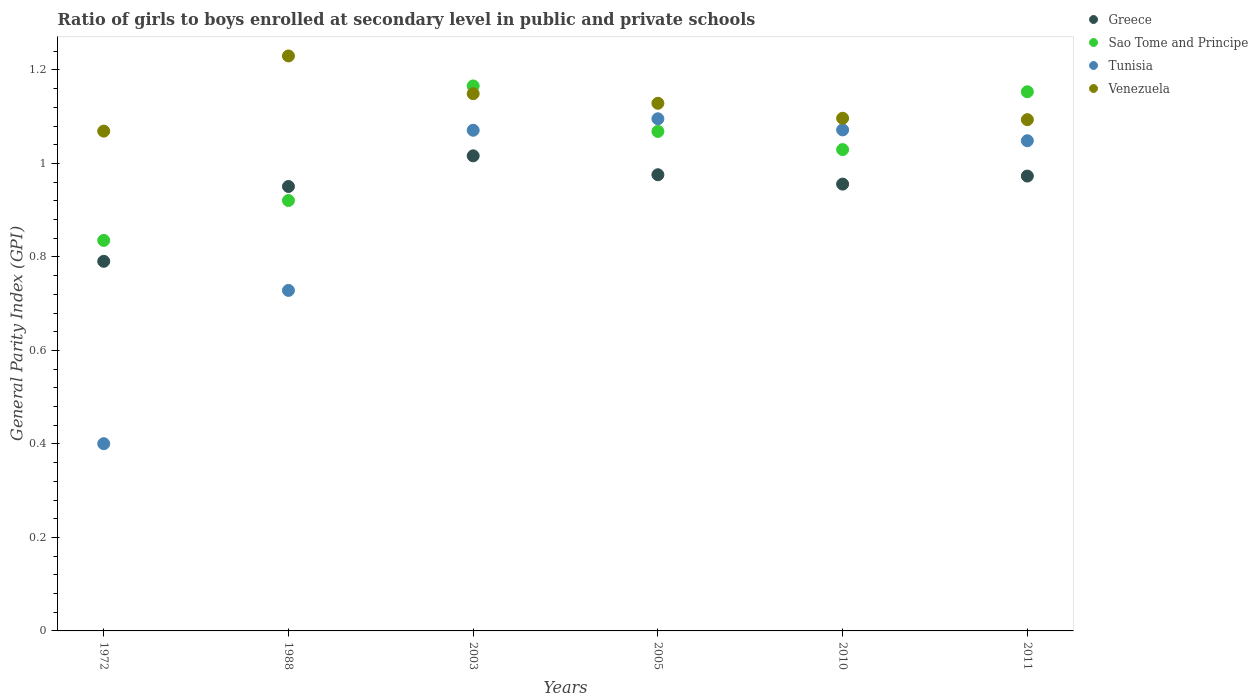Is the number of dotlines equal to the number of legend labels?
Keep it short and to the point. Yes. What is the general parity index in Greece in 1988?
Your answer should be very brief. 0.95. Across all years, what is the maximum general parity index in Sao Tome and Principe?
Give a very brief answer. 1.17. Across all years, what is the minimum general parity index in Venezuela?
Offer a terse response. 1.07. In which year was the general parity index in Greece maximum?
Provide a short and direct response. 2003. In which year was the general parity index in Venezuela minimum?
Provide a succinct answer. 1972. What is the total general parity index in Sao Tome and Principe in the graph?
Your response must be concise. 6.17. What is the difference between the general parity index in Sao Tome and Principe in 1972 and that in 2010?
Your answer should be compact. -0.19. What is the difference between the general parity index in Greece in 1988 and the general parity index in Venezuela in 2005?
Give a very brief answer. -0.18. What is the average general parity index in Tunisia per year?
Your answer should be compact. 0.9. In the year 2005, what is the difference between the general parity index in Tunisia and general parity index in Venezuela?
Offer a terse response. -0.03. In how many years, is the general parity index in Venezuela greater than 1.2000000000000002?
Offer a terse response. 1. What is the ratio of the general parity index in Venezuela in 1988 to that in 2003?
Provide a short and direct response. 1.07. What is the difference between the highest and the second highest general parity index in Greece?
Offer a very short reply. 0.04. What is the difference between the highest and the lowest general parity index in Venezuela?
Offer a very short reply. 0.16. In how many years, is the general parity index in Venezuela greater than the average general parity index in Venezuela taken over all years?
Make the answer very short. 3. Is the sum of the general parity index in Sao Tome and Principe in 2003 and 2010 greater than the maximum general parity index in Tunisia across all years?
Ensure brevity in your answer.  Yes. Is it the case that in every year, the sum of the general parity index in Sao Tome and Principe and general parity index in Venezuela  is greater than the sum of general parity index in Greece and general parity index in Tunisia?
Give a very brief answer. No. Is it the case that in every year, the sum of the general parity index in Venezuela and general parity index in Tunisia  is greater than the general parity index in Greece?
Ensure brevity in your answer.  Yes. How many dotlines are there?
Give a very brief answer. 4. What is the difference between two consecutive major ticks on the Y-axis?
Provide a short and direct response. 0.2. Does the graph contain any zero values?
Your response must be concise. No. How many legend labels are there?
Ensure brevity in your answer.  4. What is the title of the graph?
Keep it short and to the point. Ratio of girls to boys enrolled at secondary level in public and private schools. What is the label or title of the Y-axis?
Provide a succinct answer. General Parity Index (GPI). What is the General Parity Index (GPI) of Greece in 1972?
Offer a very short reply. 0.79. What is the General Parity Index (GPI) in Sao Tome and Principe in 1972?
Provide a short and direct response. 0.84. What is the General Parity Index (GPI) in Tunisia in 1972?
Offer a terse response. 0.4. What is the General Parity Index (GPI) of Venezuela in 1972?
Provide a succinct answer. 1.07. What is the General Parity Index (GPI) of Greece in 1988?
Make the answer very short. 0.95. What is the General Parity Index (GPI) in Sao Tome and Principe in 1988?
Offer a terse response. 0.92. What is the General Parity Index (GPI) of Tunisia in 1988?
Your answer should be compact. 0.73. What is the General Parity Index (GPI) of Venezuela in 1988?
Give a very brief answer. 1.23. What is the General Parity Index (GPI) of Greece in 2003?
Your answer should be very brief. 1.02. What is the General Parity Index (GPI) in Sao Tome and Principe in 2003?
Provide a short and direct response. 1.17. What is the General Parity Index (GPI) in Tunisia in 2003?
Keep it short and to the point. 1.07. What is the General Parity Index (GPI) of Venezuela in 2003?
Your answer should be compact. 1.15. What is the General Parity Index (GPI) of Greece in 2005?
Your response must be concise. 0.98. What is the General Parity Index (GPI) of Sao Tome and Principe in 2005?
Your answer should be compact. 1.07. What is the General Parity Index (GPI) of Tunisia in 2005?
Give a very brief answer. 1.1. What is the General Parity Index (GPI) in Venezuela in 2005?
Your answer should be compact. 1.13. What is the General Parity Index (GPI) in Greece in 2010?
Give a very brief answer. 0.96. What is the General Parity Index (GPI) of Sao Tome and Principe in 2010?
Make the answer very short. 1.03. What is the General Parity Index (GPI) in Tunisia in 2010?
Provide a succinct answer. 1.07. What is the General Parity Index (GPI) of Venezuela in 2010?
Ensure brevity in your answer.  1.1. What is the General Parity Index (GPI) of Greece in 2011?
Provide a succinct answer. 0.97. What is the General Parity Index (GPI) in Sao Tome and Principe in 2011?
Provide a short and direct response. 1.15. What is the General Parity Index (GPI) in Tunisia in 2011?
Your response must be concise. 1.05. What is the General Parity Index (GPI) of Venezuela in 2011?
Give a very brief answer. 1.09. Across all years, what is the maximum General Parity Index (GPI) of Greece?
Offer a very short reply. 1.02. Across all years, what is the maximum General Parity Index (GPI) of Sao Tome and Principe?
Ensure brevity in your answer.  1.17. Across all years, what is the maximum General Parity Index (GPI) in Tunisia?
Your answer should be very brief. 1.1. Across all years, what is the maximum General Parity Index (GPI) in Venezuela?
Your answer should be very brief. 1.23. Across all years, what is the minimum General Parity Index (GPI) in Greece?
Offer a terse response. 0.79. Across all years, what is the minimum General Parity Index (GPI) in Sao Tome and Principe?
Offer a very short reply. 0.84. Across all years, what is the minimum General Parity Index (GPI) of Tunisia?
Keep it short and to the point. 0.4. Across all years, what is the minimum General Parity Index (GPI) in Venezuela?
Make the answer very short. 1.07. What is the total General Parity Index (GPI) in Greece in the graph?
Make the answer very short. 5.66. What is the total General Parity Index (GPI) of Sao Tome and Principe in the graph?
Ensure brevity in your answer.  6.17. What is the total General Parity Index (GPI) of Tunisia in the graph?
Your response must be concise. 5.42. What is the total General Parity Index (GPI) in Venezuela in the graph?
Your response must be concise. 6.77. What is the difference between the General Parity Index (GPI) of Greece in 1972 and that in 1988?
Keep it short and to the point. -0.16. What is the difference between the General Parity Index (GPI) in Sao Tome and Principe in 1972 and that in 1988?
Give a very brief answer. -0.09. What is the difference between the General Parity Index (GPI) in Tunisia in 1972 and that in 1988?
Your answer should be compact. -0.33. What is the difference between the General Parity Index (GPI) of Venezuela in 1972 and that in 1988?
Give a very brief answer. -0.16. What is the difference between the General Parity Index (GPI) of Greece in 1972 and that in 2003?
Offer a very short reply. -0.23. What is the difference between the General Parity Index (GPI) of Sao Tome and Principe in 1972 and that in 2003?
Provide a succinct answer. -0.33. What is the difference between the General Parity Index (GPI) in Tunisia in 1972 and that in 2003?
Your answer should be compact. -0.67. What is the difference between the General Parity Index (GPI) in Venezuela in 1972 and that in 2003?
Make the answer very short. -0.08. What is the difference between the General Parity Index (GPI) of Greece in 1972 and that in 2005?
Offer a very short reply. -0.19. What is the difference between the General Parity Index (GPI) of Sao Tome and Principe in 1972 and that in 2005?
Provide a short and direct response. -0.23. What is the difference between the General Parity Index (GPI) in Tunisia in 1972 and that in 2005?
Provide a succinct answer. -0.69. What is the difference between the General Parity Index (GPI) in Venezuela in 1972 and that in 2005?
Your response must be concise. -0.06. What is the difference between the General Parity Index (GPI) of Greece in 1972 and that in 2010?
Give a very brief answer. -0.17. What is the difference between the General Parity Index (GPI) of Sao Tome and Principe in 1972 and that in 2010?
Your answer should be very brief. -0.19. What is the difference between the General Parity Index (GPI) of Tunisia in 1972 and that in 2010?
Offer a terse response. -0.67. What is the difference between the General Parity Index (GPI) in Venezuela in 1972 and that in 2010?
Provide a succinct answer. -0.03. What is the difference between the General Parity Index (GPI) of Greece in 1972 and that in 2011?
Provide a succinct answer. -0.18. What is the difference between the General Parity Index (GPI) in Sao Tome and Principe in 1972 and that in 2011?
Ensure brevity in your answer.  -0.32. What is the difference between the General Parity Index (GPI) in Tunisia in 1972 and that in 2011?
Your response must be concise. -0.65. What is the difference between the General Parity Index (GPI) in Venezuela in 1972 and that in 2011?
Make the answer very short. -0.02. What is the difference between the General Parity Index (GPI) in Greece in 1988 and that in 2003?
Offer a terse response. -0.07. What is the difference between the General Parity Index (GPI) of Sao Tome and Principe in 1988 and that in 2003?
Keep it short and to the point. -0.25. What is the difference between the General Parity Index (GPI) in Tunisia in 1988 and that in 2003?
Give a very brief answer. -0.34. What is the difference between the General Parity Index (GPI) of Venezuela in 1988 and that in 2003?
Your response must be concise. 0.08. What is the difference between the General Parity Index (GPI) in Greece in 1988 and that in 2005?
Give a very brief answer. -0.03. What is the difference between the General Parity Index (GPI) of Sao Tome and Principe in 1988 and that in 2005?
Offer a terse response. -0.15. What is the difference between the General Parity Index (GPI) of Tunisia in 1988 and that in 2005?
Give a very brief answer. -0.37. What is the difference between the General Parity Index (GPI) of Venezuela in 1988 and that in 2005?
Provide a succinct answer. 0.1. What is the difference between the General Parity Index (GPI) in Greece in 1988 and that in 2010?
Your response must be concise. -0.01. What is the difference between the General Parity Index (GPI) in Sao Tome and Principe in 1988 and that in 2010?
Your answer should be compact. -0.11. What is the difference between the General Parity Index (GPI) of Tunisia in 1988 and that in 2010?
Provide a succinct answer. -0.34. What is the difference between the General Parity Index (GPI) in Venezuela in 1988 and that in 2010?
Give a very brief answer. 0.13. What is the difference between the General Parity Index (GPI) in Greece in 1988 and that in 2011?
Ensure brevity in your answer.  -0.02. What is the difference between the General Parity Index (GPI) in Sao Tome and Principe in 1988 and that in 2011?
Make the answer very short. -0.23. What is the difference between the General Parity Index (GPI) in Tunisia in 1988 and that in 2011?
Ensure brevity in your answer.  -0.32. What is the difference between the General Parity Index (GPI) of Venezuela in 1988 and that in 2011?
Offer a terse response. 0.14. What is the difference between the General Parity Index (GPI) in Greece in 2003 and that in 2005?
Offer a very short reply. 0.04. What is the difference between the General Parity Index (GPI) of Sao Tome and Principe in 2003 and that in 2005?
Your answer should be compact. 0.1. What is the difference between the General Parity Index (GPI) in Tunisia in 2003 and that in 2005?
Give a very brief answer. -0.02. What is the difference between the General Parity Index (GPI) in Venezuela in 2003 and that in 2005?
Offer a terse response. 0.02. What is the difference between the General Parity Index (GPI) of Greece in 2003 and that in 2010?
Ensure brevity in your answer.  0.06. What is the difference between the General Parity Index (GPI) in Sao Tome and Principe in 2003 and that in 2010?
Provide a succinct answer. 0.14. What is the difference between the General Parity Index (GPI) in Tunisia in 2003 and that in 2010?
Keep it short and to the point. -0. What is the difference between the General Parity Index (GPI) of Venezuela in 2003 and that in 2010?
Give a very brief answer. 0.05. What is the difference between the General Parity Index (GPI) in Greece in 2003 and that in 2011?
Offer a very short reply. 0.04. What is the difference between the General Parity Index (GPI) in Sao Tome and Principe in 2003 and that in 2011?
Keep it short and to the point. 0.01. What is the difference between the General Parity Index (GPI) of Tunisia in 2003 and that in 2011?
Give a very brief answer. 0.02. What is the difference between the General Parity Index (GPI) of Venezuela in 2003 and that in 2011?
Your answer should be very brief. 0.06. What is the difference between the General Parity Index (GPI) of Greece in 2005 and that in 2010?
Give a very brief answer. 0.02. What is the difference between the General Parity Index (GPI) of Sao Tome and Principe in 2005 and that in 2010?
Give a very brief answer. 0.04. What is the difference between the General Parity Index (GPI) in Tunisia in 2005 and that in 2010?
Offer a very short reply. 0.02. What is the difference between the General Parity Index (GPI) in Venezuela in 2005 and that in 2010?
Offer a terse response. 0.03. What is the difference between the General Parity Index (GPI) of Greece in 2005 and that in 2011?
Provide a short and direct response. 0. What is the difference between the General Parity Index (GPI) of Sao Tome and Principe in 2005 and that in 2011?
Your answer should be compact. -0.08. What is the difference between the General Parity Index (GPI) in Tunisia in 2005 and that in 2011?
Give a very brief answer. 0.05. What is the difference between the General Parity Index (GPI) of Venezuela in 2005 and that in 2011?
Ensure brevity in your answer.  0.04. What is the difference between the General Parity Index (GPI) of Greece in 2010 and that in 2011?
Offer a very short reply. -0.02. What is the difference between the General Parity Index (GPI) of Sao Tome and Principe in 2010 and that in 2011?
Provide a succinct answer. -0.12. What is the difference between the General Parity Index (GPI) of Tunisia in 2010 and that in 2011?
Offer a terse response. 0.02. What is the difference between the General Parity Index (GPI) of Venezuela in 2010 and that in 2011?
Give a very brief answer. 0. What is the difference between the General Parity Index (GPI) of Greece in 1972 and the General Parity Index (GPI) of Sao Tome and Principe in 1988?
Provide a succinct answer. -0.13. What is the difference between the General Parity Index (GPI) in Greece in 1972 and the General Parity Index (GPI) in Tunisia in 1988?
Give a very brief answer. 0.06. What is the difference between the General Parity Index (GPI) of Greece in 1972 and the General Parity Index (GPI) of Venezuela in 1988?
Offer a very short reply. -0.44. What is the difference between the General Parity Index (GPI) of Sao Tome and Principe in 1972 and the General Parity Index (GPI) of Tunisia in 1988?
Ensure brevity in your answer.  0.11. What is the difference between the General Parity Index (GPI) in Sao Tome and Principe in 1972 and the General Parity Index (GPI) in Venezuela in 1988?
Provide a succinct answer. -0.39. What is the difference between the General Parity Index (GPI) of Tunisia in 1972 and the General Parity Index (GPI) of Venezuela in 1988?
Give a very brief answer. -0.83. What is the difference between the General Parity Index (GPI) of Greece in 1972 and the General Parity Index (GPI) of Sao Tome and Principe in 2003?
Give a very brief answer. -0.38. What is the difference between the General Parity Index (GPI) in Greece in 1972 and the General Parity Index (GPI) in Tunisia in 2003?
Your answer should be very brief. -0.28. What is the difference between the General Parity Index (GPI) in Greece in 1972 and the General Parity Index (GPI) in Venezuela in 2003?
Provide a succinct answer. -0.36. What is the difference between the General Parity Index (GPI) in Sao Tome and Principe in 1972 and the General Parity Index (GPI) in Tunisia in 2003?
Your answer should be compact. -0.24. What is the difference between the General Parity Index (GPI) in Sao Tome and Principe in 1972 and the General Parity Index (GPI) in Venezuela in 2003?
Provide a short and direct response. -0.31. What is the difference between the General Parity Index (GPI) in Tunisia in 1972 and the General Parity Index (GPI) in Venezuela in 2003?
Provide a short and direct response. -0.75. What is the difference between the General Parity Index (GPI) in Greece in 1972 and the General Parity Index (GPI) in Sao Tome and Principe in 2005?
Your answer should be compact. -0.28. What is the difference between the General Parity Index (GPI) of Greece in 1972 and the General Parity Index (GPI) of Tunisia in 2005?
Your answer should be very brief. -0.3. What is the difference between the General Parity Index (GPI) in Greece in 1972 and the General Parity Index (GPI) in Venezuela in 2005?
Your answer should be compact. -0.34. What is the difference between the General Parity Index (GPI) of Sao Tome and Principe in 1972 and the General Parity Index (GPI) of Tunisia in 2005?
Ensure brevity in your answer.  -0.26. What is the difference between the General Parity Index (GPI) of Sao Tome and Principe in 1972 and the General Parity Index (GPI) of Venezuela in 2005?
Offer a terse response. -0.29. What is the difference between the General Parity Index (GPI) of Tunisia in 1972 and the General Parity Index (GPI) of Venezuela in 2005?
Your answer should be very brief. -0.73. What is the difference between the General Parity Index (GPI) in Greece in 1972 and the General Parity Index (GPI) in Sao Tome and Principe in 2010?
Your response must be concise. -0.24. What is the difference between the General Parity Index (GPI) of Greece in 1972 and the General Parity Index (GPI) of Tunisia in 2010?
Offer a terse response. -0.28. What is the difference between the General Parity Index (GPI) of Greece in 1972 and the General Parity Index (GPI) of Venezuela in 2010?
Your response must be concise. -0.31. What is the difference between the General Parity Index (GPI) in Sao Tome and Principe in 1972 and the General Parity Index (GPI) in Tunisia in 2010?
Provide a short and direct response. -0.24. What is the difference between the General Parity Index (GPI) in Sao Tome and Principe in 1972 and the General Parity Index (GPI) in Venezuela in 2010?
Your answer should be compact. -0.26. What is the difference between the General Parity Index (GPI) of Tunisia in 1972 and the General Parity Index (GPI) of Venezuela in 2010?
Your answer should be very brief. -0.7. What is the difference between the General Parity Index (GPI) of Greece in 1972 and the General Parity Index (GPI) of Sao Tome and Principe in 2011?
Give a very brief answer. -0.36. What is the difference between the General Parity Index (GPI) of Greece in 1972 and the General Parity Index (GPI) of Tunisia in 2011?
Provide a succinct answer. -0.26. What is the difference between the General Parity Index (GPI) in Greece in 1972 and the General Parity Index (GPI) in Venezuela in 2011?
Your answer should be compact. -0.3. What is the difference between the General Parity Index (GPI) in Sao Tome and Principe in 1972 and the General Parity Index (GPI) in Tunisia in 2011?
Provide a short and direct response. -0.21. What is the difference between the General Parity Index (GPI) in Sao Tome and Principe in 1972 and the General Parity Index (GPI) in Venezuela in 2011?
Give a very brief answer. -0.26. What is the difference between the General Parity Index (GPI) of Tunisia in 1972 and the General Parity Index (GPI) of Venezuela in 2011?
Keep it short and to the point. -0.69. What is the difference between the General Parity Index (GPI) of Greece in 1988 and the General Parity Index (GPI) of Sao Tome and Principe in 2003?
Give a very brief answer. -0.22. What is the difference between the General Parity Index (GPI) in Greece in 1988 and the General Parity Index (GPI) in Tunisia in 2003?
Keep it short and to the point. -0.12. What is the difference between the General Parity Index (GPI) of Greece in 1988 and the General Parity Index (GPI) of Venezuela in 2003?
Your response must be concise. -0.2. What is the difference between the General Parity Index (GPI) in Sao Tome and Principe in 1988 and the General Parity Index (GPI) in Tunisia in 2003?
Your answer should be compact. -0.15. What is the difference between the General Parity Index (GPI) in Sao Tome and Principe in 1988 and the General Parity Index (GPI) in Venezuela in 2003?
Your answer should be very brief. -0.23. What is the difference between the General Parity Index (GPI) of Tunisia in 1988 and the General Parity Index (GPI) of Venezuela in 2003?
Keep it short and to the point. -0.42. What is the difference between the General Parity Index (GPI) of Greece in 1988 and the General Parity Index (GPI) of Sao Tome and Principe in 2005?
Provide a short and direct response. -0.12. What is the difference between the General Parity Index (GPI) of Greece in 1988 and the General Parity Index (GPI) of Tunisia in 2005?
Your answer should be compact. -0.14. What is the difference between the General Parity Index (GPI) in Greece in 1988 and the General Parity Index (GPI) in Venezuela in 2005?
Keep it short and to the point. -0.18. What is the difference between the General Parity Index (GPI) of Sao Tome and Principe in 1988 and the General Parity Index (GPI) of Tunisia in 2005?
Ensure brevity in your answer.  -0.17. What is the difference between the General Parity Index (GPI) in Sao Tome and Principe in 1988 and the General Parity Index (GPI) in Venezuela in 2005?
Offer a very short reply. -0.21. What is the difference between the General Parity Index (GPI) of Tunisia in 1988 and the General Parity Index (GPI) of Venezuela in 2005?
Provide a short and direct response. -0.4. What is the difference between the General Parity Index (GPI) of Greece in 1988 and the General Parity Index (GPI) of Sao Tome and Principe in 2010?
Your response must be concise. -0.08. What is the difference between the General Parity Index (GPI) of Greece in 1988 and the General Parity Index (GPI) of Tunisia in 2010?
Your response must be concise. -0.12. What is the difference between the General Parity Index (GPI) in Greece in 1988 and the General Parity Index (GPI) in Venezuela in 2010?
Make the answer very short. -0.15. What is the difference between the General Parity Index (GPI) in Sao Tome and Principe in 1988 and the General Parity Index (GPI) in Tunisia in 2010?
Ensure brevity in your answer.  -0.15. What is the difference between the General Parity Index (GPI) in Sao Tome and Principe in 1988 and the General Parity Index (GPI) in Venezuela in 2010?
Ensure brevity in your answer.  -0.18. What is the difference between the General Parity Index (GPI) of Tunisia in 1988 and the General Parity Index (GPI) of Venezuela in 2010?
Provide a short and direct response. -0.37. What is the difference between the General Parity Index (GPI) in Greece in 1988 and the General Parity Index (GPI) in Sao Tome and Principe in 2011?
Offer a very short reply. -0.2. What is the difference between the General Parity Index (GPI) of Greece in 1988 and the General Parity Index (GPI) of Tunisia in 2011?
Make the answer very short. -0.1. What is the difference between the General Parity Index (GPI) in Greece in 1988 and the General Parity Index (GPI) in Venezuela in 2011?
Ensure brevity in your answer.  -0.14. What is the difference between the General Parity Index (GPI) in Sao Tome and Principe in 1988 and the General Parity Index (GPI) in Tunisia in 2011?
Offer a very short reply. -0.13. What is the difference between the General Parity Index (GPI) of Sao Tome and Principe in 1988 and the General Parity Index (GPI) of Venezuela in 2011?
Make the answer very short. -0.17. What is the difference between the General Parity Index (GPI) of Tunisia in 1988 and the General Parity Index (GPI) of Venezuela in 2011?
Keep it short and to the point. -0.37. What is the difference between the General Parity Index (GPI) in Greece in 2003 and the General Parity Index (GPI) in Sao Tome and Principe in 2005?
Make the answer very short. -0.05. What is the difference between the General Parity Index (GPI) of Greece in 2003 and the General Parity Index (GPI) of Tunisia in 2005?
Ensure brevity in your answer.  -0.08. What is the difference between the General Parity Index (GPI) of Greece in 2003 and the General Parity Index (GPI) of Venezuela in 2005?
Offer a terse response. -0.11. What is the difference between the General Parity Index (GPI) of Sao Tome and Principe in 2003 and the General Parity Index (GPI) of Tunisia in 2005?
Offer a terse response. 0.07. What is the difference between the General Parity Index (GPI) in Sao Tome and Principe in 2003 and the General Parity Index (GPI) in Venezuela in 2005?
Your response must be concise. 0.04. What is the difference between the General Parity Index (GPI) in Tunisia in 2003 and the General Parity Index (GPI) in Venezuela in 2005?
Your answer should be compact. -0.06. What is the difference between the General Parity Index (GPI) in Greece in 2003 and the General Parity Index (GPI) in Sao Tome and Principe in 2010?
Offer a very short reply. -0.01. What is the difference between the General Parity Index (GPI) in Greece in 2003 and the General Parity Index (GPI) in Tunisia in 2010?
Offer a terse response. -0.06. What is the difference between the General Parity Index (GPI) of Greece in 2003 and the General Parity Index (GPI) of Venezuela in 2010?
Your answer should be very brief. -0.08. What is the difference between the General Parity Index (GPI) in Sao Tome and Principe in 2003 and the General Parity Index (GPI) in Tunisia in 2010?
Keep it short and to the point. 0.09. What is the difference between the General Parity Index (GPI) in Sao Tome and Principe in 2003 and the General Parity Index (GPI) in Venezuela in 2010?
Your response must be concise. 0.07. What is the difference between the General Parity Index (GPI) of Tunisia in 2003 and the General Parity Index (GPI) of Venezuela in 2010?
Your response must be concise. -0.03. What is the difference between the General Parity Index (GPI) in Greece in 2003 and the General Parity Index (GPI) in Sao Tome and Principe in 2011?
Your answer should be very brief. -0.14. What is the difference between the General Parity Index (GPI) in Greece in 2003 and the General Parity Index (GPI) in Tunisia in 2011?
Make the answer very short. -0.03. What is the difference between the General Parity Index (GPI) of Greece in 2003 and the General Parity Index (GPI) of Venezuela in 2011?
Provide a succinct answer. -0.08. What is the difference between the General Parity Index (GPI) in Sao Tome and Principe in 2003 and the General Parity Index (GPI) in Tunisia in 2011?
Your answer should be very brief. 0.12. What is the difference between the General Parity Index (GPI) of Sao Tome and Principe in 2003 and the General Parity Index (GPI) of Venezuela in 2011?
Ensure brevity in your answer.  0.07. What is the difference between the General Parity Index (GPI) in Tunisia in 2003 and the General Parity Index (GPI) in Venezuela in 2011?
Your answer should be very brief. -0.02. What is the difference between the General Parity Index (GPI) of Greece in 2005 and the General Parity Index (GPI) of Sao Tome and Principe in 2010?
Give a very brief answer. -0.05. What is the difference between the General Parity Index (GPI) of Greece in 2005 and the General Parity Index (GPI) of Tunisia in 2010?
Offer a very short reply. -0.1. What is the difference between the General Parity Index (GPI) in Greece in 2005 and the General Parity Index (GPI) in Venezuela in 2010?
Your answer should be compact. -0.12. What is the difference between the General Parity Index (GPI) of Sao Tome and Principe in 2005 and the General Parity Index (GPI) of Tunisia in 2010?
Your answer should be very brief. -0. What is the difference between the General Parity Index (GPI) in Sao Tome and Principe in 2005 and the General Parity Index (GPI) in Venezuela in 2010?
Offer a terse response. -0.03. What is the difference between the General Parity Index (GPI) in Tunisia in 2005 and the General Parity Index (GPI) in Venezuela in 2010?
Offer a terse response. -0. What is the difference between the General Parity Index (GPI) in Greece in 2005 and the General Parity Index (GPI) in Sao Tome and Principe in 2011?
Offer a terse response. -0.18. What is the difference between the General Parity Index (GPI) of Greece in 2005 and the General Parity Index (GPI) of Tunisia in 2011?
Offer a terse response. -0.07. What is the difference between the General Parity Index (GPI) of Greece in 2005 and the General Parity Index (GPI) of Venezuela in 2011?
Give a very brief answer. -0.12. What is the difference between the General Parity Index (GPI) of Sao Tome and Principe in 2005 and the General Parity Index (GPI) of Tunisia in 2011?
Give a very brief answer. 0.02. What is the difference between the General Parity Index (GPI) in Sao Tome and Principe in 2005 and the General Parity Index (GPI) in Venezuela in 2011?
Give a very brief answer. -0.03. What is the difference between the General Parity Index (GPI) of Tunisia in 2005 and the General Parity Index (GPI) of Venezuela in 2011?
Your answer should be very brief. 0. What is the difference between the General Parity Index (GPI) in Greece in 2010 and the General Parity Index (GPI) in Sao Tome and Principe in 2011?
Your answer should be very brief. -0.2. What is the difference between the General Parity Index (GPI) of Greece in 2010 and the General Parity Index (GPI) of Tunisia in 2011?
Your answer should be very brief. -0.09. What is the difference between the General Parity Index (GPI) of Greece in 2010 and the General Parity Index (GPI) of Venezuela in 2011?
Provide a succinct answer. -0.14. What is the difference between the General Parity Index (GPI) in Sao Tome and Principe in 2010 and the General Parity Index (GPI) in Tunisia in 2011?
Offer a terse response. -0.02. What is the difference between the General Parity Index (GPI) of Sao Tome and Principe in 2010 and the General Parity Index (GPI) of Venezuela in 2011?
Offer a terse response. -0.06. What is the difference between the General Parity Index (GPI) in Tunisia in 2010 and the General Parity Index (GPI) in Venezuela in 2011?
Offer a terse response. -0.02. What is the average General Parity Index (GPI) in Greece per year?
Your answer should be very brief. 0.94. What is the average General Parity Index (GPI) in Sao Tome and Principe per year?
Give a very brief answer. 1.03. What is the average General Parity Index (GPI) of Tunisia per year?
Your response must be concise. 0.9. What is the average General Parity Index (GPI) in Venezuela per year?
Offer a very short reply. 1.13. In the year 1972, what is the difference between the General Parity Index (GPI) of Greece and General Parity Index (GPI) of Sao Tome and Principe?
Your answer should be very brief. -0.04. In the year 1972, what is the difference between the General Parity Index (GPI) in Greece and General Parity Index (GPI) in Tunisia?
Your response must be concise. 0.39. In the year 1972, what is the difference between the General Parity Index (GPI) in Greece and General Parity Index (GPI) in Venezuela?
Your answer should be very brief. -0.28. In the year 1972, what is the difference between the General Parity Index (GPI) of Sao Tome and Principe and General Parity Index (GPI) of Tunisia?
Give a very brief answer. 0.43. In the year 1972, what is the difference between the General Parity Index (GPI) of Sao Tome and Principe and General Parity Index (GPI) of Venezuela?
Offer a terse response. -0.23. In the year 1972, what is the difference between the General Parity Index (GPI) of Tunisia and General Parity Index (GPI) of Venezuela?
Ensure brevity in your answer.  -0.67. In the year 1988, what is the difference between the General Parity Index (GPI) in Greece and General Parity Index (GPI) in Sao Tome and Principe?
Keep it short and to the point. 0.03. In the year 1988, what is the difference between the General Parity Index (GPI) of Greece and General Parity Index (GPI) of Tunisia?
Your response must be concise. 0.22. In the year 1988, what is the difference between the General Parity Index (GPI) in Greece and General Parity Index (GPI) in Venezuela?
Offer a terse response. -0.28. In the year 1988, what is the difference between the General Parity Index (GPI) of Sao Tome and Principe and General Parity Index (GPI) of Tunisia?
Your answer should be very brief. 0.19. In the year 1988, what is the difference between the General Parity Index (GPI) of Sao Tome and Principe and General Parity Index (GPI) of Venezuela?
Give a very brief answer. -0.31. In the year 1988, what is the difference between the General Parity Index (GPI) of Tunisia and General Parity Index (GPI) of Venezuela?
Give a very brief answer. -0.5. In the year 2003, what is the difference between the General Parity Index (GPI) in Greece and General Parity Index (GPI) in Sao Tome and Principe?
Keep it short and to the point. -0.15. In the year 2003, what is the difference between the General Parity Index (GPI) in Greece and General Parity Index (GPI) in Tunisia?
Offer a terse response. -0.05. In the year 2003, what is the difference between the General Parity Index (GPI) of Greece and General Parity Index (GPI) of Venezuela?
Offer a terse response. -0.13. In the year 2003, what is the difference between the General Parity Index (GPI) in Sao Tome and Principe and General Parity Index (GPI) in Tunisia?
Offer a very short reply. 0.09. In the year 2003, what is the difference between the General Parity Index (GPI) of Sao Tome and Principe and General Parity Index (GPI) of Venezuela?
Make the answer very short. 0.02. In the year 2003, what is the difference between the General Parity Index (GPI) of Tunisia and General Parity Index (GPI) of Venezuela?
Provide a short and direct response. -0.08. In the year 2005, what is the difference between the General Parity Index (GPI) in Greece and General Parity Index (GPI) in Sao Tome and Principe?
Your answer should be compact. -0.09. In the year 2005, what is the difference between the General Parity Index (GPI) of Greece and General Parity Index (GPI) of Tunisia?
Your response must be concise. -0.12. In the year 2005, what is the difference between the General Parity Index (GPI) in Greece and General Parity Index (GPI) in Venezuela?
Your answer should be very brief. -0.15. In the year 2005, what is the difference between the General Parity Index (GPI) of Sao Tome and Principe and General Parity Index (GPI) of Tunisia?
Offer a terse response. -0.03. In the year 2005, what is the difference between the General Parity Index (GPI) of Sao Tome and Principe and General Parity Index (GPI) of Venezuela?
Provide a succinct answer. -0.06. In the year 2005, what is the difference between the General Parity Index (GPI) in Tunisia and General Parity Index (GPI) in Venezuela?
Keep it short and to the point. -0.03. In the year 2010, what is the difference between the General Parity Index (GPI) of Greece and General Parity Index (GPI) of Sao Tome and Principe?
Your answer should be compact. -0.07. In the year 2010, what is the difference between the General Parity Index (GPI) in Greece and General Parity Index (GPI) in Tunisia?
Provide a succinct answer. -0.12. In the year 2010, what is the difference between the General Parity Index (GPI) in Greece and General Parity Index (GPI) in Venezuela?
Give a very brief answer. -0.14. In the year 2010, what is the difference between the General Parity Index (GPI) of Sao Tome and Principe and General Parity Index (GPI) of Tunisia?
Ensure brevity in your answer.  -0.04. In the year 2010, what is the difference between the General Parity Index (GPI) of Sao Tome and Principe and General Parity Index (GPI) of Venezuela?
Offer a terse response. -0.07. In the year 2010, what is the difference between the General Parity Index (GPI) in Tunisia and General Parity Index (GPI) in Venezuela?
Offer a terse response. -0.02. In the year 2011, what is the difference between the General Parity Index (GPI) in Greece and General Parity Index (GPI) in Sao Tome and Principe?
Ensure brevity in your answer.  -0.18. In the year 2011, what is the difference between the General Parity Index (GPI) of Greece and General Parity Index (GPI) of Tunisia?
Keep it short and to the point. -0.08. In the year 2011, what is the difference between the General Parity Index (GPI) in Greece and General Parity Index (GPI) in Venezuela?
Offer a very short reply. -0.12. In the year 2011, what is the difference between the General Parity Index (GPI) of Sao Tome and Principe and General Parity Index (GPI) of Tunisia?
Give a very brief answer. 0.1. In the year 2011, what is the difference between the General Parity Index (GPI) of Sao Tome and Principe and General Parity Index (GPI) of Venezuela?
Ensure brevity in your answer.  0.06. In the year 2011, what is the difference between the General Parity Index (GPI) in Tunisia and General Parity Index (GPI) in Venezuela?
Ensure brevity in your answer.  -0.05. What is the ratio of the General Parity Index (GPI) in Greece in 1972 to that in 1988?
Your answer should be compact. 0.83. What is the ratio of the General Parity Index (GPI) of Sao Tome and Principe in 1972 to that in 1988?
Provide a succinct answer. 0.91. What is the ratio of the General Parity Index (GPI) in Tunisia in 1972 to that in 1988?
Offer a terse response. 0.55. What is the ratio of the General Parity Index (GPI) in Venezuela in 1972 to that in 1988?
Make the answer very short. 0.87. What is the ratio of the General Parity Index (GPI) in Greece in 1972 to that in 2003?
Ensure brevity in your answer.  0.78. What is the ratio of the General Parity Index (GPI) in Sao Tome and Principe in 1972 to that in 2003?
Offer a terse response. 0.72. What is the ratio of the General Parity Index (GPI) in Tunisia in 1972 to that in 2003?
Keep it short and to the point. 0.37. What is the ratio of the General Parity Index (GPI) of Venezuela in 1972 to that in 2003?
Make the answer very short. 0.93. What is the ratio of the General Parity Index (GPI) in Greece in 1972 to that in 2005?
Your response must be concise. 0.81. What is the ratio of the General Parity Index (GPI) of Sao Tome and Principe in 1972 to that in 2005?
Your answer should be very brief. 0.78. What is the ratio of the General Parity Index (GPI) of Tunisia in 1972 to that in 2005?
Keep it short and to the point. 0.37. What is the ratio of the General Parity Index (GPI) in Venezuela in 1972 to that in 2005?
Your answer should be very brief. 0.95. What is the ratio of the General Parity Index (GPI) in Greece in 1972 to that in 2010?
Provide a succinct answer. 0.83. What is the ratio of the General Parity Index (GPI) of Sao Tome and Principe in 1972 to that in 2010?
Offer a very short reply. 0.81. What is the ratio of the General Parity Index (GPI) in Tunisia in 1972 to that in 2010?
Give a very brief answer. 0.37. What is the ratio of the General Parity Index (GPI) of Venezuela in 1972 to that in 2010?
Your answer should be compact. 0.97. What is the ratio of the General Parity Index (GPI) of Greece in 1972 to that in 2011?
Make the answer very short. 0.81. What is the ratio of the General Parity Index (GPI) of Sao Tome and Principe in 1972 to that in 2011?
Your answer should be very brief. 0.72. What is the ratio of the General Parity Index (GPI) of Tunisia in 1972 to that in 2011?
Offer a terse response. 0.38. What is the ratio of the General Parity Index (GPI) in Venezuela in 1972 to that in 2011?
Make the answer very short. 0.98. What is the ratio of the General Parity Index (GPI) of Greece in 1988 to that in 2003?
Provide a short and direct response. 0.94. What is the ratio of the General Parity Index (GPI) in Sao Tome and Principe in 1988 to that in 2003?
Your response must be concise. 0.79. What is the ratio of the General Parity Index (GPI) of Tunisia in 1988 to that in 2003?
Keep it short and to the point. 0.68. What is the ratio of the General Parity Index (GPI) of Venezuela in 1988 to that in 2003?
Provide a short and direct response. 1.07. What is the ratio of the General Parity Index (GPI) in Greece in 1988 to that in 2005?
Your answer should be very brief. 0.97. What is the ratio of the General Parity Index (GPI) in Sao Tome and Principe in 1988 to that in 2005?
Your response must be concise. 0.86. What is the ratio of the General Parity Index (GPI) of Tunisia in 1988 to that in 2005?
Make the answer very short. 0.66. What is the ratio of the General Parity Index (GPI) of Venezuela in 1988 to that in 2005?
Ensure brevity in your answer.  1.09. What is the ratio of the General Parity Index (GPI) in Greece in 1988 to that in 2010?
Give a very brief answer. 0.99. What is the ratio of the General Parity Index (GPI) of Sao Tome and Principe in 1988 to that in 2010?
Make the answer very short. 0.89. What is the ratio of the General Parity Index (GPI) in Tunisia in 1988 to that in 2010?
Your response must be concise. 0.68. What is the ratio of the General Parity Index (GPI) in Venezuela in 1988 to that in 2010?
Provide a succinct answer. 1.12. What is the ratio of the General Parity Index (GPI) in Greece in 1988 to that in 2011?
Your response must be concise. 0.98. What is the ratio of the General Parity Index (GPI) of Sao Tome and Principe in 1988 to that in 2011?
Your response must be concise. 0.8. What is the ratio of the General Parity Index (GPI) in Tunisia in 1988 to that in 2011?
Your response must be concise. 0.69. What is the ratio of the General Parity Index (GPI) in Venezuela in 1988 to that in 2011?
Your response must be concise. 1.12. What is the ratio of the General Parity Index (GPI) of Greece in 2003 to that in 2005?
Your answer should be compact. 1.04. What is the ratio of the General Parity Index (GPI) of Sao Tome and Principe in 2003 to that in 2005?
Keep it short and to the point. 1.09. What is the ratio of the General Parity Index (GPI) of Tunisia in 2003 to that in 2005?
Your answer should be compact. 0.98. What is the ratio of the General Parity Index (GPI) of Venezuela in 2003 to that in 2005?
Provide a short and direct response. 1.02. What is the ratio of the General Parity Index (GPI) of Greece in 2003 to that in 2010?
Ensure brevity in your answer.  1.06. What is the ratio of the General Parity Index (GPI) in Sao Tome and Principe in 2003 to that in 2010?
Offer a very short reply. 1.13. What is the ratio of the General Parity Index (GPI) of Tunisia in 2003 to that in 2010?
Your answer should be compact. 1. What is the ratio of the General Parity Index (GPI) in Venezuela in 2003 to that in 2010?
Offer a terse response. 1.05. What is the ratio of the General Parity Index (GPI) in Greece in 2003 to that in 2011?
Keep it short and to the point. 1.04. What is the ratio of the General Parity Index (GPI) of Sao Tome and Principe in 2003 to that in 2011?
Offer a very short reply. 1.01. What is the ratio of the General Parity Index (GPI) in Tunisia in 2003 to that in 2011?
Keep it short and to the point. 1.02. What is the ratio of the General Parity Index (GPI) of Venezuela in 2003 to that in 2011?
Ensure brevity in your answer.  1.05. What is the ratio of the General Parity Index (GPI) of Greece in 2005 to that in 2010?
Your response must be concise. 1.02. What is the ratio of the General Parity Index (GPI) in Sao Tome and Principe in 2005 to that in 2010?
Your response must be concise. 1.04. What is the ratio of the General Parity Index (GPI) in Tunisia in 2005 to that in 2010?
Provide a succinct answer. 1.02. What is the ratio of the General Parity Index (GPI) in Venezuela in 2005 to that in 2010?
Offer a terse response. 1.03. What is the ratio of the General Parity Index (GPI) of Sao Tome and Principe in 2005 to that in 2011?
Ensure brevity in your answer.  0.93. What is the ratio of the General Parity Index (GPI) in Tunisia in 2005 to that in 2011?
Keep it short and to the point. 1.04. What is the ratio of the General Parity Index (GPI) in Venezuela in 2005 to that in 2011?
Make the answer very short. 1.03. What is the ratio of the General Parity Index (GPI) in Greece in 2010 to that in 2011?
Provide a succinct answer. 0.98. What is the ratio of the General Parity Index (GPI) in Sao Tome and Principe in 2010 to that in 2011?
Your answer should be compact. 0.89. What is the ratio of the General Parity Index (GPI) in Tunisia in 2010 to that in 2011?
Provide a succinct answer. 1.02. What is the difference between the highest and the second highest General Parity Index (GPI) in Greece?
Ensure brevity in your answer.  0.04. What is the difference between the highest and the second highest General Parity Index (GPI) in Sao Tome and Principe?
Keep it short and to the point. 0.01. What is the difference between the highest and the second highest General Parity Index (GPI) of Tunisia?
Provide a short and direct response. 0.02. What is the difference between the highest and the second highest General Parity Index (GPI) of Venezuela?
Your answer should be compact. 0.08. What is the difference between the highest and the lowest General Parity Index (GPI) of Greece?
Keep it short and to the point. 0.23. What is the difference between the highest and the lowest General Parity Index (GPI) in Sao Tome and Principe?
Make the answer very short. 0.33. What is the difference between the highest and the lowest General Parity Index (GPI) of Tunisia?
Your answer should be compact. 0.69. What is the difference between the highest and the lowest General Parity Index (GPI) of Venezuela?
Provide a succinct answer. 0.16. 